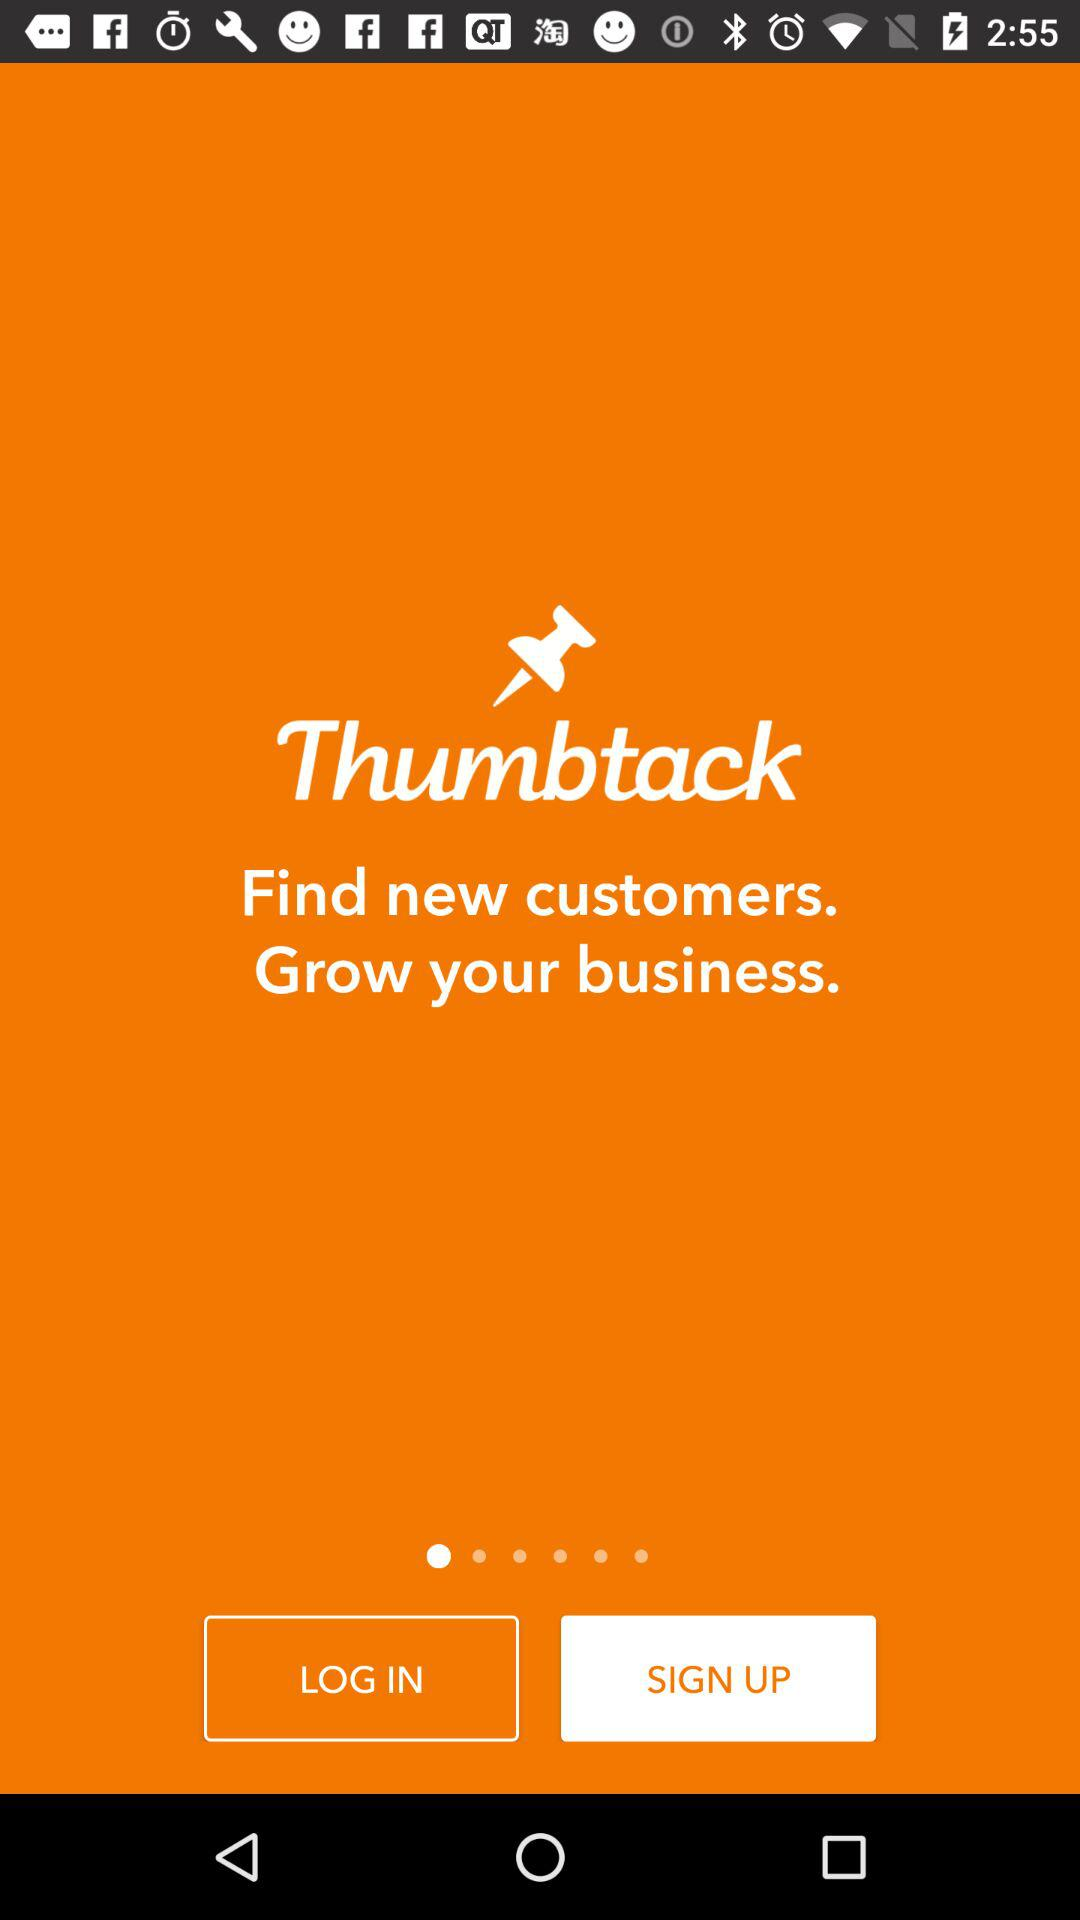What's the application name? The application name is "Thumbtack". 